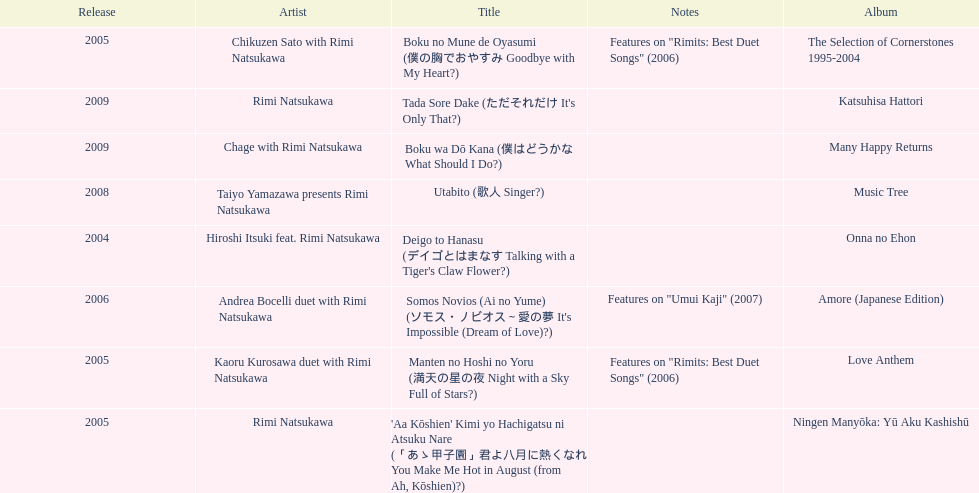What was the album issued right before the one with boku wa do kana in it? Music Tree. 